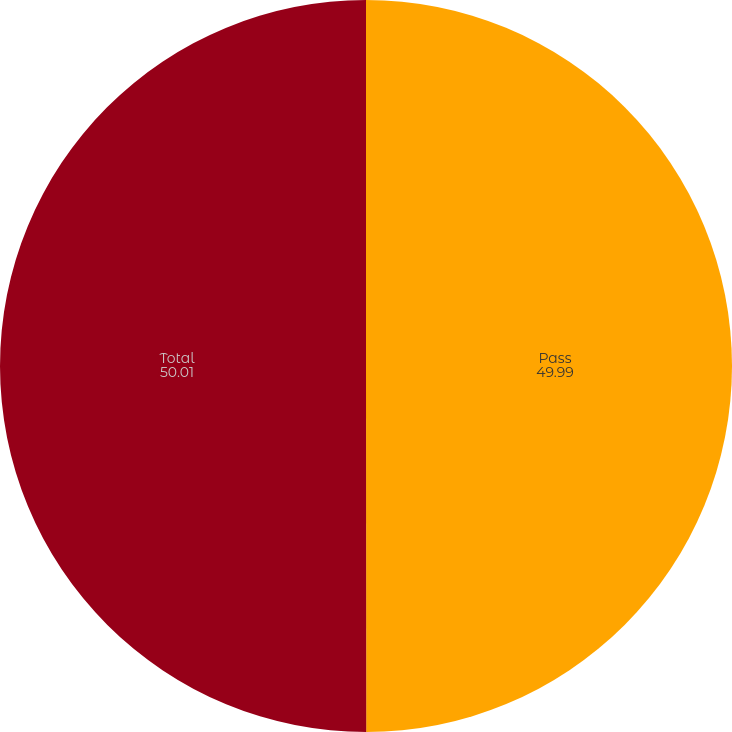Convert chart. <chart><loc_0><loc_0><loc_500><loc_500><pie_chart><fcel>Pass<fcel>Total<nl><fcel>49.99%<fcel>50.01%<nl></chart> 